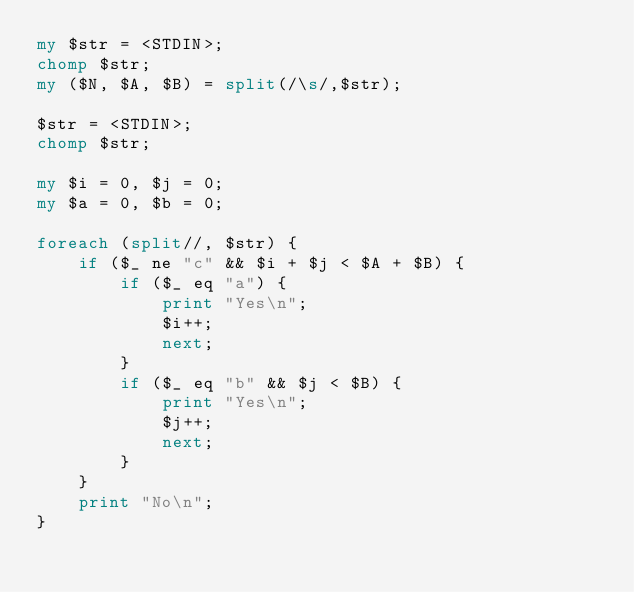<code> <loc_0><loc_0><loc_500><loc_500><_Perl_>my $str = <STDIN>;
chomp $str;
my ($N, $A, $B) = split(/\s/,$str);

$str = <STDIN>;
chomp $str;

my $i = 0, $j = 0;
my $a = 0, $b = 0;

foreach (split//, $str) {
    if ($_ ne "c" && $i + $j < $A + $B) {
        if ($_ eq "a") {
            print "Yes\n";
            $i++;
            next;
        }
        if ($_ eq "b" && $j < $B) {
            print "Yes\n";
            $j++;
            next;
        } 
    }
    print "No\n";
}</code> 